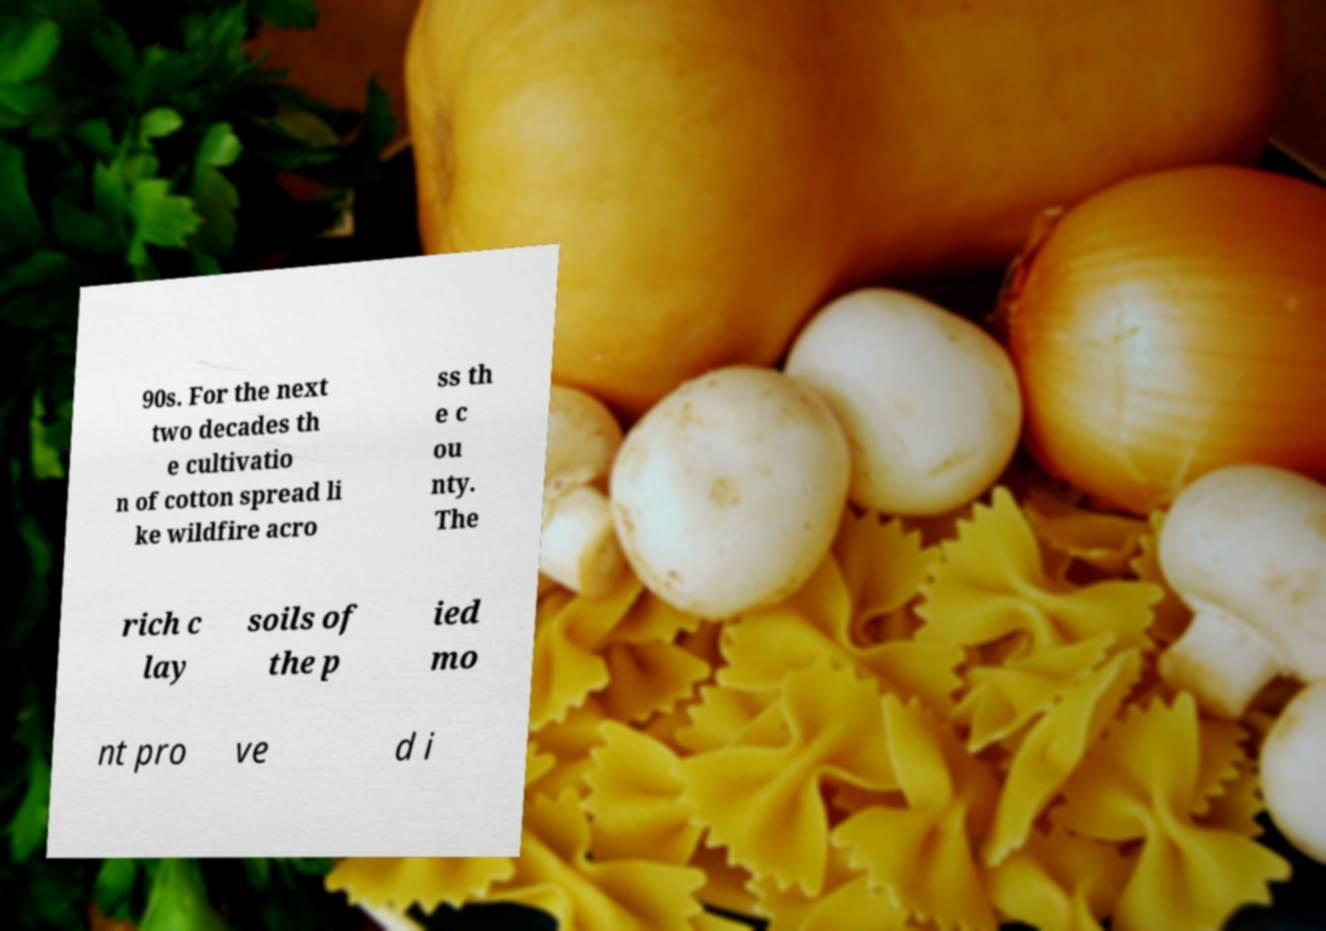Can you accurately transcribe the text from the provided image for me? 90s. For the next two decades th e cultivatio n of cotton spread li ke wildfire acro ss th e c ou nty. The rich c lay soils of the p ied mo nt pro ve d i 